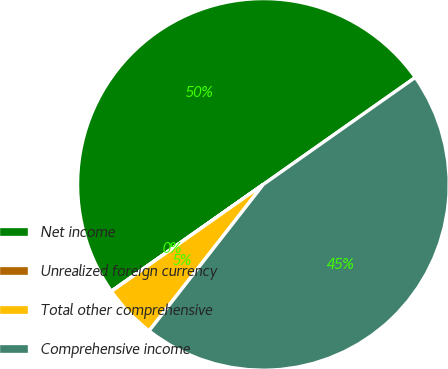Convert chart to OTSL. <chart><loc_0><loc_0><loc_500><loc_500><pie_chart><fcel>Net income<fcel>Unrealized foreign currency<fcel>Total other comprehensive<fcel>Comprehensive income<nl><fcel>49.98%<fcel>0.02%<fcel>4.69%<fcel>45.31%<nl></chart> 